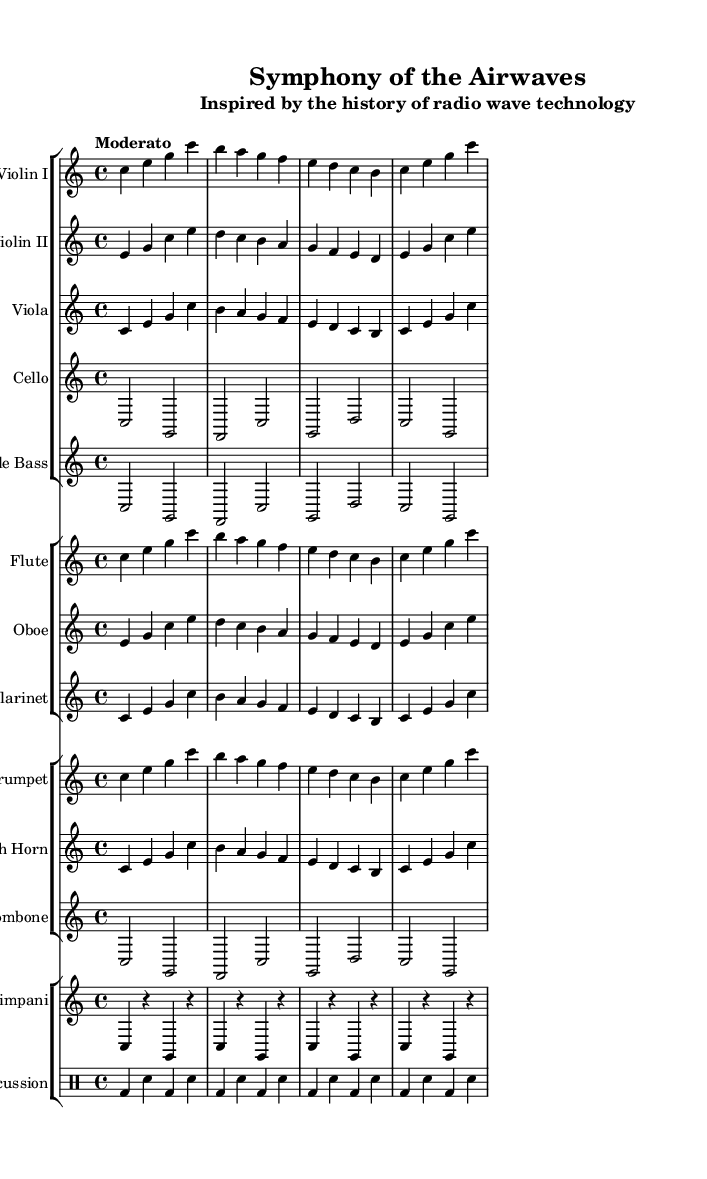What is the key signature of this music? The key signature is C major, which has no sharps or flats.
Answer: C major What is the time signature of this music? The time signature is indicated as 4/4, which means there are four beats in a measure.
Answer: 4/4 What is the tempo marking for this symphony? The tempo marking is noted as "Moderato", indicating a moderate pace.
Answer: Moderato How many different instrument groups are represented in this symphony? There are four distinct groups of instruments: strings, woodwinds, brass, and percussion.
Answer: Four Which instrument plays the lowest notes in this symphony? The cello and double bass sections are indicated with lower note ranges compared to other instruments.
Answer: Cello and Double Bass What rhythmic figure is predominantly used in the percussion section? The percussion section features a consistent pattern of bass drum and snare drum alternating in a repetitive rhythm.
Answer: Alternating bass and snare What is the first note played by Violin I? The first note played by Violin I is C, as indicated at the beginning of the staff.
Answer: C 